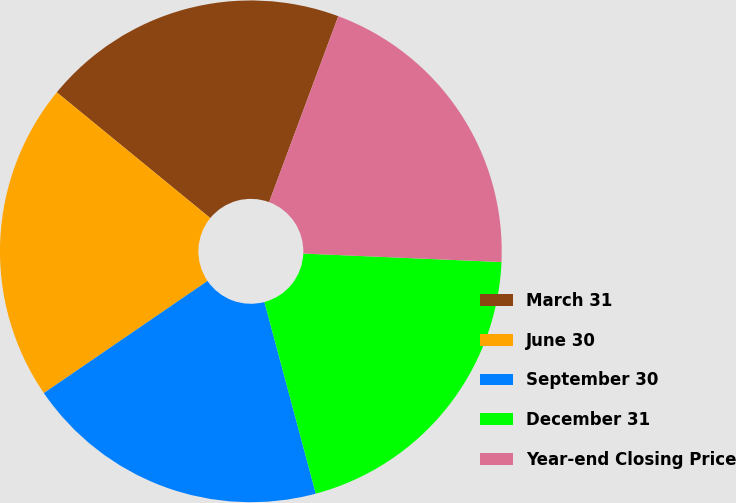Convert chart. <chart><loc_0><loc_0><loc_500><loc_500><pie_chart><fcel>March 31<fcel>June 30<fcel>September 30<fcel>December 31<fcel>Year-end Closing Price<nl><fcel>19.74%<fcel>20.48%<fcel>19.61%<fcel>20.15%<fcel>20.01%<nl></chart> 